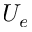<formula> <loc_0><loc_0><loc_500><loc_500>U _ { e }</formula> 